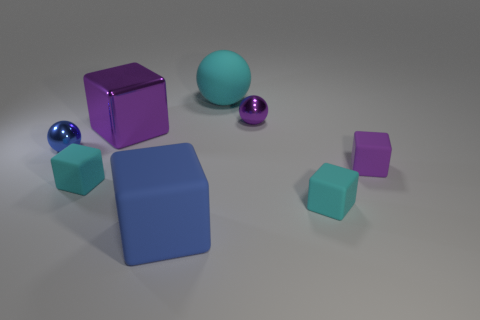Subtract all cyan cubes. How many were subtracted if there are1cyan cubes left? 1 Subtract all blue blocks. How many blocks are left? 4 Subtract 2 cubes. How many cubes are left? 3 Subtract all big blue rubber blocks. How many blocks are left? 4 Add 1 blue rubber blocks. How many objects exist? 9 Subtract all yellow blocks. Subtract all blue cylinders. How many blocks are left? 5 Subtract 2 purple blocks. How many objects are left? 6 Subtract all balls. How many objects are left? 5 Subtract all large balls. Subtract all cyan blocks. How many objects are left? 5 Add 5 small cyan things. How many small cyan things are left? 7 